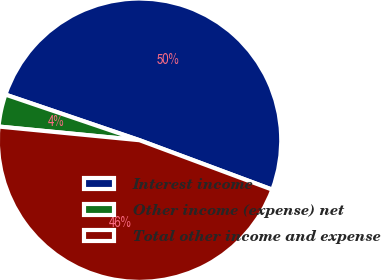<chart> <loc_0><loc_0><loc_500><loc_500><pie_chart><fcel>Interest income<fcel>Other income (expense) net<fcel>Total other income and expense<nl><fcel>50.46%<fcel>3.68%<fcel>45.87%<nl></chart> 